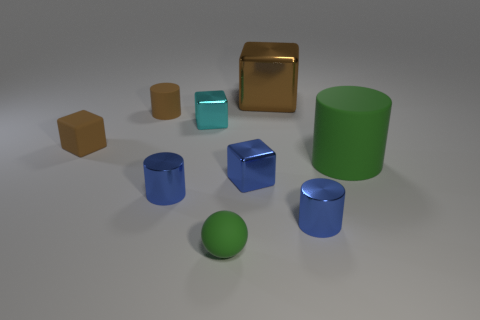There is a green thing that is behind the blue shiny object that is left of the green rubber thing on the left side of the big rubber thing; what is it made of?
Your response must be concise. Rubber. There is a object that is behind the tiny cyan block and in front of the big brown block; what size is it?
Your answer should be compact. Small. How many cylinders are large yellow objects or small metallic things?
Your answer should be compact. 2. There is a cylinder that is the same size as the brown shiny block; what is its color?
Offer a very short reply. Green. Is there any other thing that is the same shape as the big matte object?
Keep it short and to the point. Yes. The other tiny metallic thing that is the same shape as the cyan metal thing is what color?
Provide a short and direct response. Blue. How many things are either big shiny things or blue objects on the left side of the large cube?
Offer a very short reply. 3. Is the number of large objects that are on the left side of the small matte sphere less than the number of rubber things?
Your answer should be compact. Yes. There is a brown cylinder left of the green sphere that is in front of the tiny shiny block that is right of the green matte sphere; how big is it?
Provide a short and direct response. Small. What is the color of the tiny rubber object that is both in front of the tiny brown matte cylinder and behind the small green ball?
Offer a terse response. Brown. 